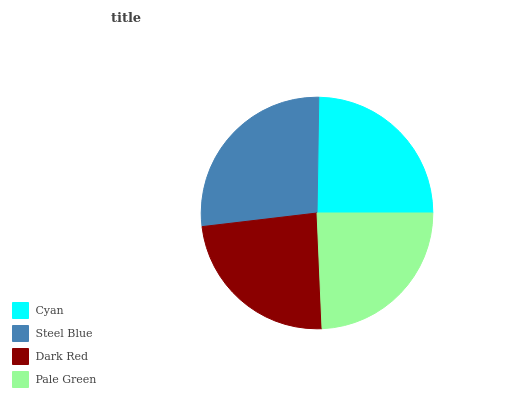Is Dark Red the minimum?
Answer yes or no. Yes. Is Steel Blue the maximum?
Answer yes or no. Yes. Is Steel Blue the minimum?
Answer yes or no. No. Is Dark Red the maximum?
Answer yes or no. No. Is Steel Blue greater than Dark Red?
Answer yes or no. Yes. Is Dark Red less than Steel Blue?
Answer yes or no. Yes. Is Dark Red greater than Steel Blue?
Answer yes or no. No. Is Steel Blue less than Dark Red?
Answer yes or no. No. Is Cyan the high median?
Answer yes or no. Yes. Is Pale Green the low median?
Answer yes or no. Yes. Is Steel Blue the high median?
Answer yes or no. No. Is Dark Red the low median?
Answer yes or no. No. 